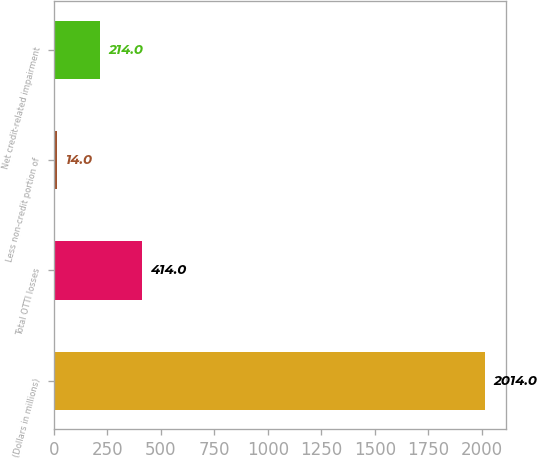Convert chart. <chart><loc_0><loc_0><loc_500><loc_500><bar_chart><fcel>(Dollars in millions)<fcel>Total OTTI losses<fcel>Less non-credit portion of<fcel>Net credit-related impairment<nl><fcel>2014<fcel>414<fcel>14<fcel>214<nl></chart> 